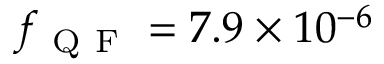<formula> <loc_0><loc_0><loc_500><loc_500>f _ { Q F } = 7 . 9 \times 1 0 ^ { - 6 }</formula> 